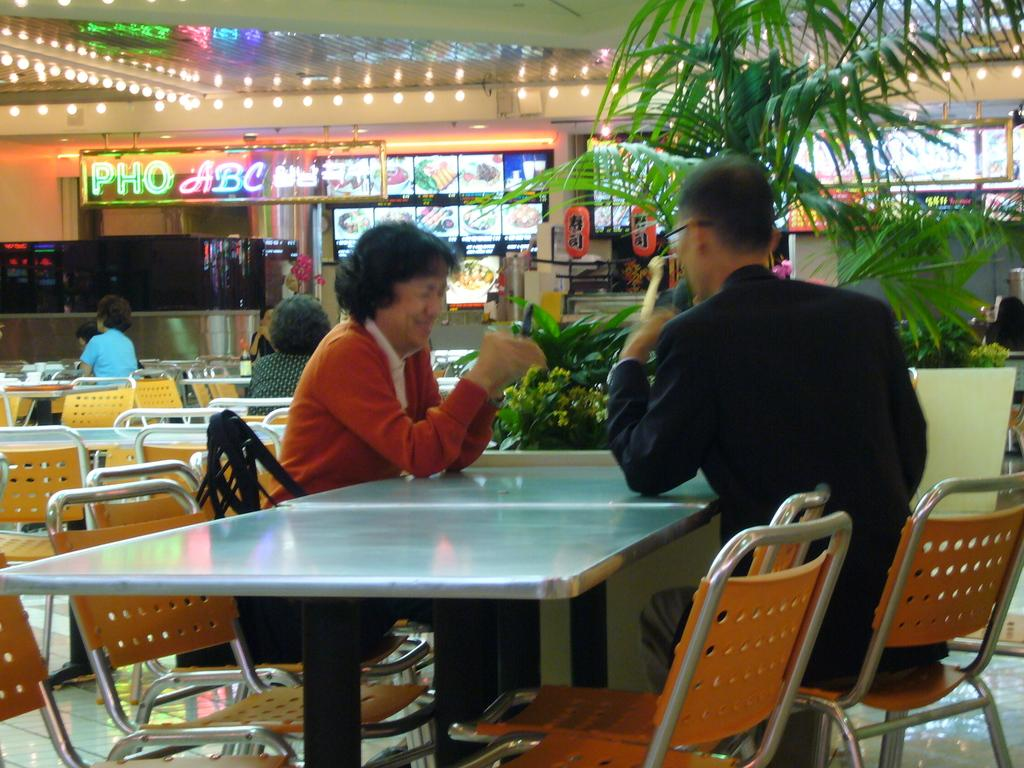How many people are in the image? There is a group of persons in the image. What are the persons in the image doing? The persons are sitting on chairs. What can be seen in the background of the image? There are plants and a food item menu displayed on a screen in the background. Can you describe the setting of the image? The persons are sitting on chairs, which suggests they might be in a dining area or a similar setting. What type of canvas is being used by the servant in the image? There is no canvas or servant present in the image. What type of frame is around the painting in the image? There is no painting or frame present in the image. 